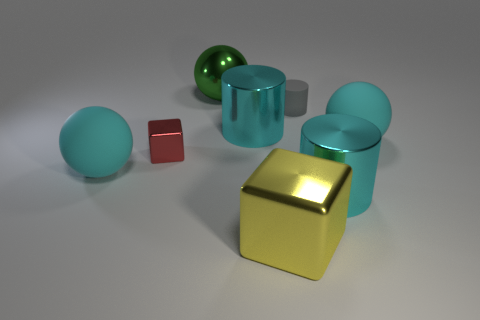The large cylinder that is on the left side of the gray thing to the right of the large green sphere is what color?
Your answer should be compact. Cyan. There is a large cyan ball that is left of the cyan sphere on the right side of the cyan cylinder right of the yellow cube; what is it made of?
Your answer should be very brief. Rubber. There is a cylinder on the left side of the yellow metallic object; does it have the same size as the tiny block?
Ensure brevity in your answer.  No. What material is the large cyan sphere to the left of the large green metal thing?
Ensure brevity in your answer.  Rubber. Is the number of big purple cylinders greater than the number of big matte spheres?
Provide a succinct answer. No. What number of objects are either rubber balls to the right of the tiny red shiny cube or big green rubber blocks?
Your answer should be compact. 1. There is a big cyan rubber object on the left side of the gray thing; what number of metallic cubes are behind it?
Give a very brief answer. 1. There is a cyan cylinder that is behind the big cyan cylinder that is in front of the cyan matte ball to the right of the big yellow block; what is its size?
Keep it short and to the point. Large. There is a cylinder to the right of the tiny gray matte thing; does it have the same color as the tiny rubber object?
Provide a short and direct response. No. What size is the red metallic object that is the same shape as the yellow shiny object?
Provide a succinct answer. Small. 